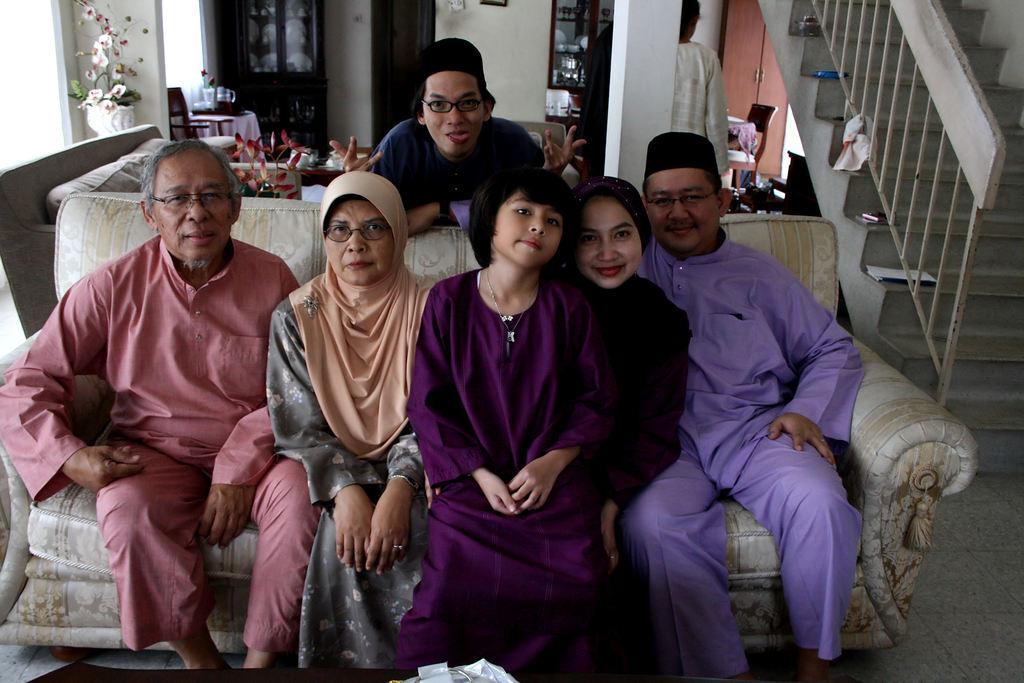Can you describe this image briefly? In this image I can see people sitting on a couch. A person is present behind them. There is a flower pot on the left. There is a white pillar, a person and cabinets at the back. There are stairs and railing on the right. 